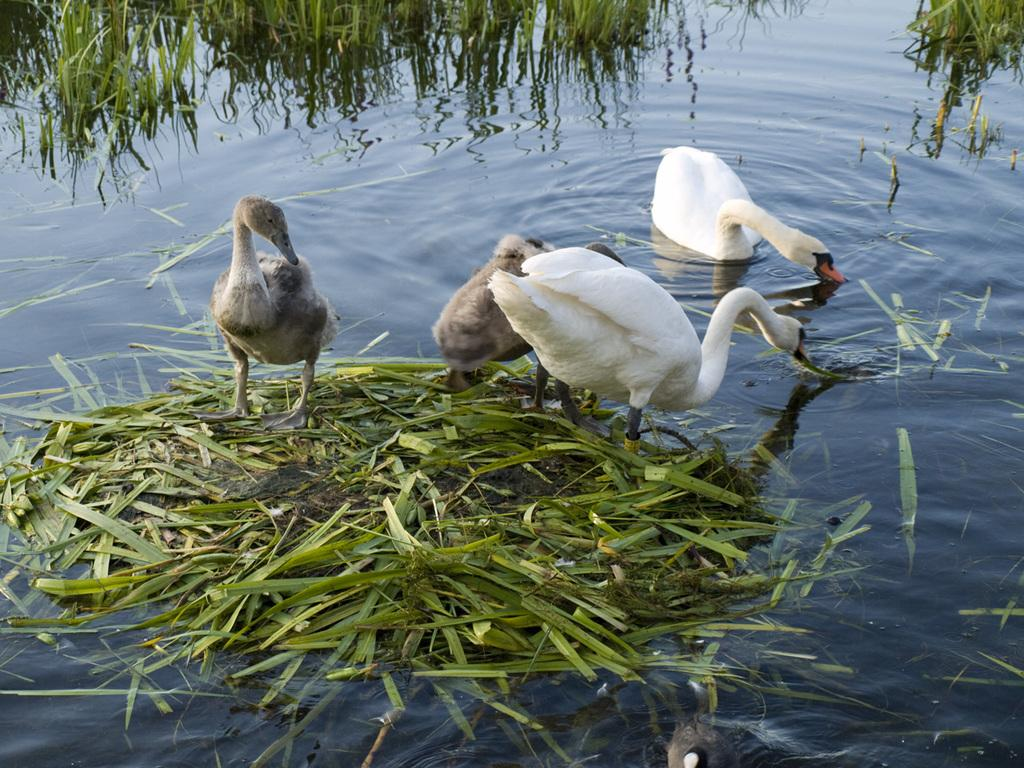How many ducks are in the image? There are two ducks in the image. How many swans are in the image? There are two swans in the image. What type of vegetation can be seen in the water? There is grass visible in the water in the image. What is the minister doing in the middle of the image? There is no minister present in the image; it features two ducks and two swans in a body of water with grass. 